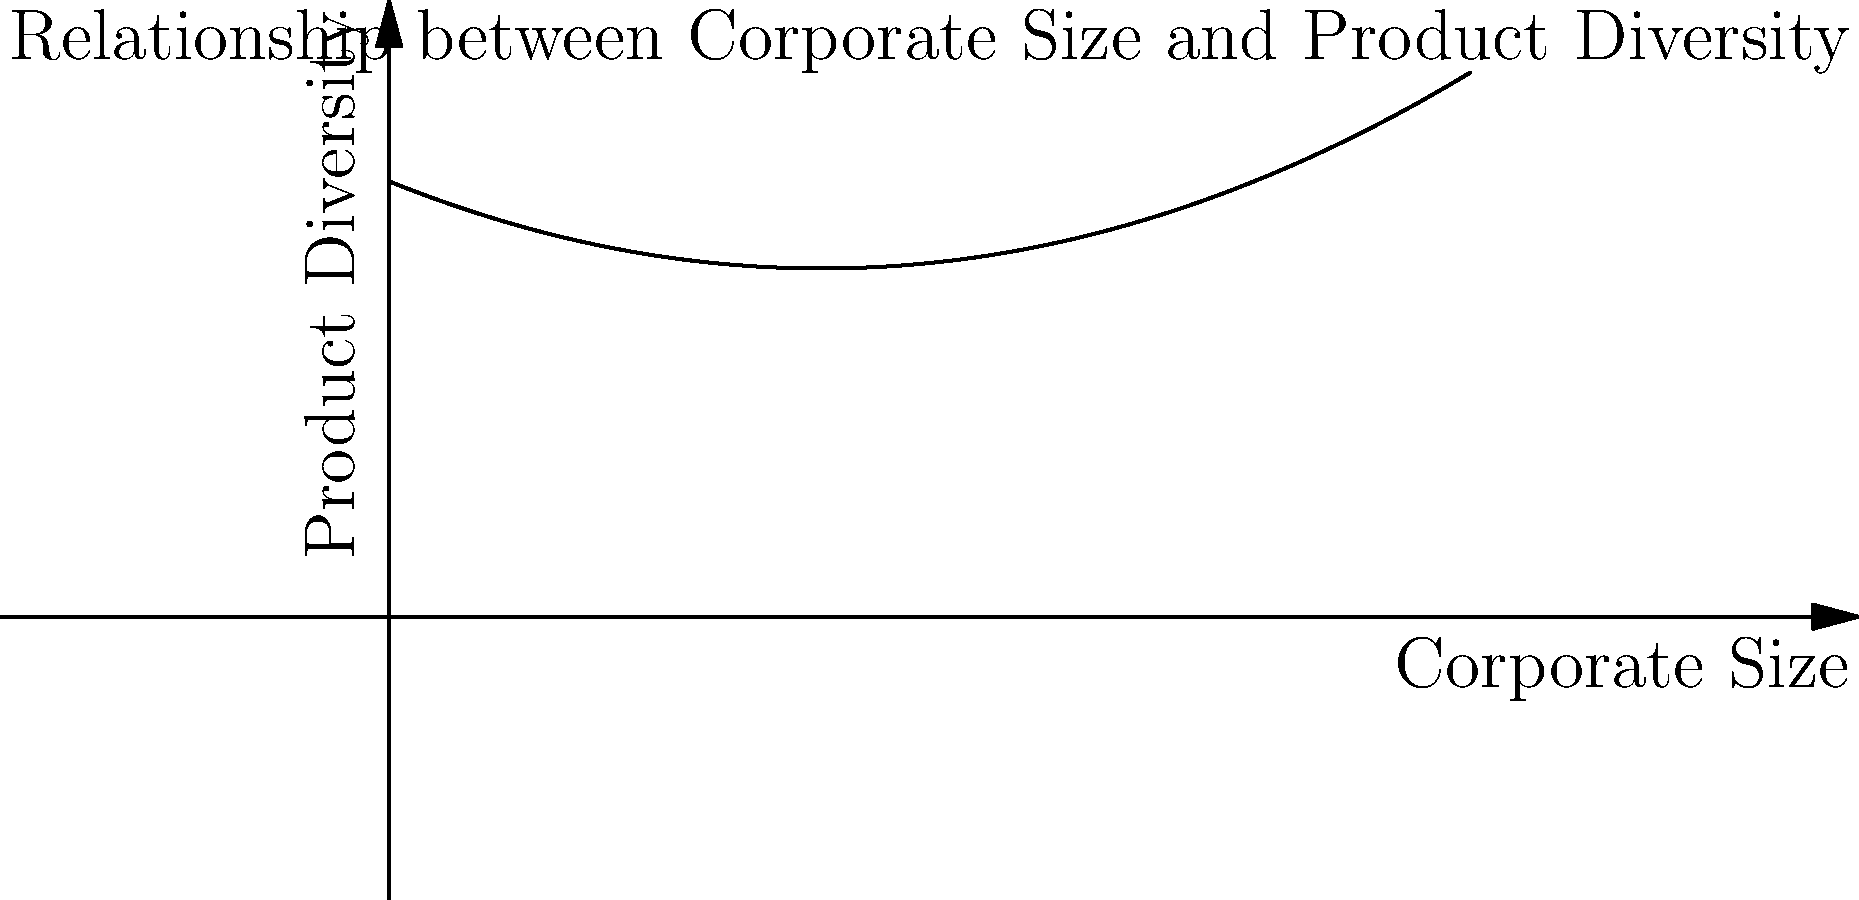Based on the line graph, how might a food industry analyst interpret the relationship between corporate size and product diversity, particularly in the context of mega corporations? To interpret this graph as a food industry analyst skeptical of mega corporations, we should follow these steps:

1. Observe the overall trend: The graph shows a U-shaped curve, indicating a non-linear relationship between corporate size and product diversity.

2. Analyze the initial decline:
   - As corporate size initially increases, product diversity decreases.
   - This could suggest that smaller companies tend to offer a wider range of products to compete in various niches.

3. Examine the turning point:
   - There's a point where the trend reverses, and product diversity starts to increase with corporate size.
   - This could represent the size at which corporations gain enough resources to diversify their product lines.

4. Consider the implications for mega corporations:
   - The graph shows that the largest corporations have the highest product diversity.
   - From a skeptical perspective, this could be interpreted as mega corporations using their vast resources to dominate multiple market segments, potentially stifling competition from smaller, specialized companies.

5. Reflect on the food industry context:
   - In the food industry, this trend might represent large corporations acquiring diverse brands or developing new product lines to capture various market segments.
   - A skeptical analyst might view this as potentially reducing true product diversity, as these diverse offerings are controlled by a small number of large entities.

6. Consider limitations:
   - The graph doesn't show absolute values, so the actual levels of diversity for small vs. large corporations are not clear.
   - It also doesn't account for factors like product quality, innovation, or market concentration.
Answer: Mega corporations may leverage their size to increase product diversity, potentially dominating multiple market segments at the expense of true market diversity and competition. 